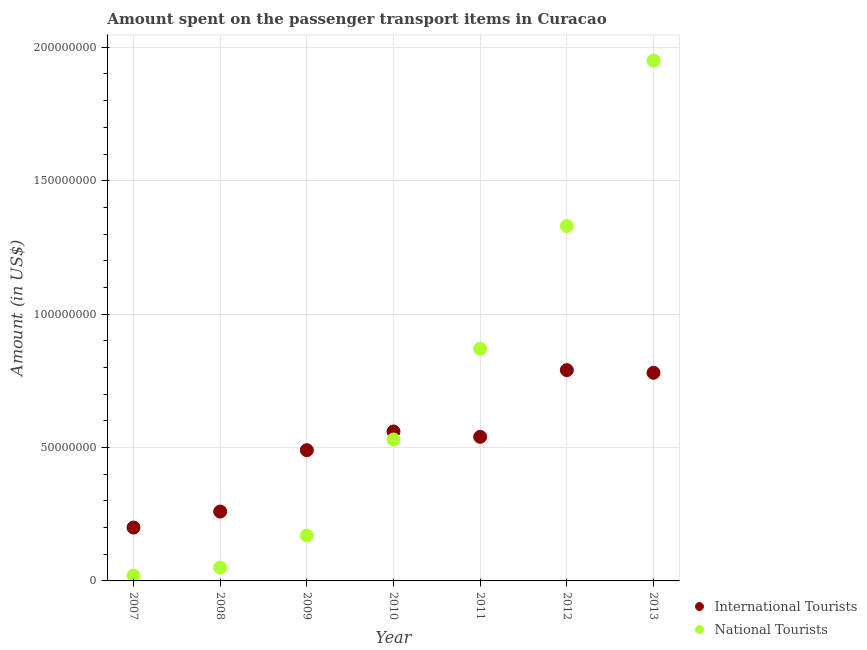Is the number of dotlines equal to the number of legend labels?
Your response must be concise. Yes. What is the amount spent on transport items of international tourists in 2008?
Your answer should be very brief. 2.60e+07. Across all years, what is the maximum amount spent on transport items of international tourists?
Give a very brief answer. 7.90e+07. Across all years, what is the minimum amount spent on transport items of national tourists?
Your answer should be compact. 2.00e+06. What is the total amount spent on transport items of national tourists in the graph?
Your response must be concise. 4.92e+08. What is the difference between the amount spent on transport items of international tourists in 2007 and that in 2008?
Your answer should be very brief. -6.00e+06. What is the difference between the amount spent on transport items of international tourists in 2011 and the amount spent on transport items of national tourists in 2009?
Provide a succinct answer. 3.70e+07. What is the average amount spent on transport items of international tourists per year?
Ensure brevity in your answer.  5.17e+07. In the year 2013, what is the difference between the amount spent on transport items of international tourists and amount spent on transport items of national tourists?
Your answer should be very brief. -1.17e+08. In how many years, is the amount spent on transport items of international tourists greater than 140000000 US$?
Your response must be concise. 0. What is the ratio of the amount spent on transport items of national tourists in 2007 to that in 2009?
Make the answer very short. 0.12. Is the amount spent on transport items of national tourists in 2007 less than that in 2008?
Your response must be concise. Yes. What is the difference between the highest and the second highest amount spent on transport items of international tourists?
Provide a succinct answer. 1.00e+06. What is the difference between the highest and the lowest amount spent on transport items of national tourists?
Your response must be concise. 1.93e+08. Is the sum of the amount spent on transport items of international tourists in 2007 and 2013 greater than the maximum amount spent on transport items of national tourists across all years?
Your answer should be compact. No. How many dotlines are there?
Offer a very short reply. 2. What is the difference between two consecutive major ticks on the Y-axis?
Your answer should be compact. 5.00e+07. Are the values on the major ticks of Y-axis written in scientific E-notation?
Provide a short and direct response. No. Does the graph contain any zero values?
Offer a terse response. No. Where does the legend appear in the graph?
Provide a succinct answer. Bottom right. How are the legend labels stacked?
Keep it short and to the point. Vertical. What is the title of the graph?
Your answer should be very brief. Amount spent on the passenger transport items in Curacao. What is the label or title of the X-axis?
Your answer should be very brief. Year. What is the Amount (in US$) in International Tourists in 2008?
Provide a succinct answer. 2.60e+07. What is the Amount (in US$) in International Tourists in 2009?
Offer a terse response. 4.90e+07. What is the Amount (in US$) in National Tourists in 2009?
Provide a succinct answer. 1.70e+07. What is the Amount (in US$) of International Tourists in 2010?
Make the answer very short. 5.60e+07. What is the Amount (in US$) of National Tourists in 2010?
Your answer should be very brief. 5.30e+07. What is the Amount (in US$) in International Tourists in 2011?
Provide a succinct answer. 5.40e+07. What is the Amount (in US$) in National Tourists in 2011?
Your response must be concise. 8.70e+07. What is the Amount (in US$) of International Tourists in 2012?
Give a very brief answer. 7.90e+07. What is the Amount (in US$) of National Tourists in 2012?
Give a very brief answer. 1.33e+08. What is the Amount (in US$) in International Tourists in 2013?
Keep it short and to the point. 7.80e+07. What is the Amount (in US$) of National Tourists in 2013?
Provide a succinct answer. 1.95e+08. Across all years, what is the maximum Amount (in US$) in International Tourists?
Your answer should be compact. 7.90e+07. Across all years, what is the maximum Amount (in US$) of National Tourists?
Give a very brief answer. 1.95e+08. Across all years, what is the minimum Amount (in US$) in National Tourists?
Make the answer very short. 2.00e+06. What is the total Amount (in US$) in International Tourists in the graph?
Keep it short and to the point. 3.62e+08. What is the total Amount (in US$) of National Tourists in the graph?
Your response must be concise. 4.92e+08. What is the difference between the Amount (in US$) in International Tourists in 2007 and that in 2008?
Offer a terse response. -6.00e+06. What is the difference between the Amount (in US$) in International Tourists in 2007 and that in 2009?
Your answer should be compact. -2.90e+07. What is the difference between the Amount (in US$) in National Tourists in 2007 and that in 2009?
Ensure brevity in your answer.  -1.50e+07. What is the difference between the Amount (in US$) of International Tourists in 2007 and that in 2010?
Offer a terse response. -3.60e+07. What is the difference between the Amount (in US$) of National Tourists in 2007 and that in 2010?
Provide a short and direct response. -5.10e+07. What is the difference between the Amount (in US$) in International Tourists in 2007 and that in 2011?
Your answer should be compact. -3.40e+07. What is the difference between the Amount (in US$) in National Tourists in 2007 and that in 2011?
Offer a terse response. -8.50e+07. What is the difference between the Amount (in US$) of International Tourists in 2007 and that in 2012?
Keep it short and to the point. -5.90e+07. What is the difference between the Amount (in US$) in National Tourists in 2007 and that in 2012?
Provide a succinct answer. -1.31e+08. What is the difference between the Amount (in US$) in International Tourists in 2007 and that in 2013?
Ensure brevity in your answer.  -5.80e+07. What is the difference between the Amount (in US$) in National Tourists in 2007 and that in 2013?
Provide a short and direct response. -1.93e+08. What is the difference between the Amount (in US$) in International Tourists in 2008 and that in 2009?
Offer a very short reply. -2.30e+07. What is the difference between the Amount (in US$) in National Tourists in 2008 and that in 2009?
Give a very brief answer. -1.20e+07. What is the difference between the Amount (in US$) in International Tourists in 2008 and that in 2010?
Offer a terse response. -3.00e+07. What is the difference between the Amount (in US$) of National Tourists in 2008 and that in 2010?
Your response must be concise. -4.80e+07. What is the difference between the Amount (in US$) in International Tourists in 2008 and that in 2011?
Provide a short and direct response. -2.80e+07. What is the difference between the Amount (in US$) in National Tourists in 2008 and that in 2011?
Offer a terse response. -8.20e+07. What is the difference between the Amount (in US$) in International Tourists in 2008 and that in 2012?
Provide a succinct answer. -5.30e+07. What is the difference between the Amount (in US$) in National Tourists in 2008 and that in 2012?
Your response must be concise. -1.28e+08. What is the difference between the Amount (in US$) of International Tourists in 2008 and that in 2013?
Provide a succinct answer. -5.20e+07. What is the difference between the Amount (in US$) in National Tourists in 2008 and that in 2013?
Give a very brief answer. -1.90e+08. What is the difference between the Amount (in US$) in International Tourists in 2009 and that in 2010?
Ensure brevity in your answer.  -7.00e+06. What is the difference between the Amount (in US$) of National Tourists in 2009 and that in 2010?
Offer a terse response. -3.60e+07. What is the difference between the Amount (in US$) in International Tourists in 2009 and that in 2011?
Provide a succinct answer. -5.00e+06. What is the difference between the Amount (in US$) in National Tourists in 2009 and that in 2011?
Keep it short and to the point. -7.00e+07. What is the difference between the Amount (in US$) of International Tourists in 2009 and that in 2012?
Give a very brief answer. -3.00e+07. What is the difference between the Amount (in US$) of National Tourists in 2009 and that in 2012?
Give a very brief answer. -1.16e+08. What is the difference between the Amount (in US$) of International Tourists in 2009 and that in 2013?
Your answer should be very brief. -2.90e+07. What is the difference between the Amount (in US$) in National Tourists in 2009 and that in 2013?
Give a very brief answer. -1.78e+08. What is the difference between the Amount (in US$) of National Tourists in 2010 and that in 2011?
Provide a short and direct response. -3.40e+07. What is the difference between the Amount (in US$) in International Tourists in 2010 and that in 2012?
Provide a short and direct response. -2.30e+07. What is the difference between the Amount (in US$) in National Tourists in 2010 and that in 2012?
Your answer should be very brief. -8.00e+07. What is the difference between the Amount (in US$) in International Tourists in 2010 and that in 2013?
Provide a short and direct response. -2.20e+07. What is the difference between the Amount (in US$) of National Tourists in 2010 and that in 2013?
Provide a succinct answer. -1.42e+08. What is the difference between the Amount (in US$) of International Tourists in 2011 and that in 2012?
Make the answer very short. -2.50e+07. What is the difference between the Amount (in US$) in National Tourists in 2011 and that in 2012?
Offer a very short reply. -4.60e+07. What is the difference between the Amount (in US$) in International Tourists in 2011 and that in 2013?
Provide a succinct answer. -2.40e+07. What is the difference between the Amount (in US$) of National Tourists in 2011 and that in 2013?
Keep it short and to the point. -1.08e+08. What is the difference between the Amount (in US$) of International Tourists in 2012 and that in 2013?
Provide a short and direct response. 1.00e+06. What is the difference between the Amount (in US$) in National Tourists in 2012 and that in 2013?
Keep it short and to the point. -6.20e+07. What is the difference between the Amount (in US$) in International Tourists in 2007 and the Amount (in US$) in National Tourists in 2008?
Your answer should be compact. 1.50e+07. What is the difference between the Amount (in US$) of International Tourists in 2007 and the Amount (in US$) of National Tourists in 2009?
Offer a very short reply. 3.00e+06. What is the difference between the Amount (in US$) in International Tourists in 2007 and the Amount (in US$) in National Tourists in 2010?
Make the answer very short. -3.30e+07. What is the difference between the Amount (in US$) in International Tourists in 2007 and the Amount (in US$) in National Tourists in 2011?
Offer a very short reply. -6.70e+07. What is the difference between the Amount (in US$) of International Tourists in 2007 and the Amount (in US$) of National Tourists in 2012?
Your answer should be very brief. -1.13e+08. What is the difference between the Amount (in US$) of International Tourists in 2007 and the Amount (in US$) of National Tourists in 2013?
Keep it short and to the point. -1.75e+08. What is the difference between the Amount (in US$) of International Tourists in 2008 and the Amount (in US$) of National Tourists in 2009?
Keep it short and to the point. 9.00e+06. What is the difference between the Amount (in US$) of International Tourists in 2008 and the Amount (in US$) of National Tourists in 2010?
Your response must be concise. -2.70e+07. What is the difference between the Amount (in US$) in International Tourists in 2008 and the Amount (in US$) in National Tourists in 2011?
Your answer should be very brief. -6.10e+07. What is the difference between the Amount (in US$) in International Tourists in 2008 and the Amount (in US$) in National Tourists in 2012?
Provide a short and direct response. -1.07e+08. What is the difference between the Amount (in US$) in International Tourists in 2008 and the Amount (in US$) in National Tourists in 2013?
Offer a very short reply. -1.69e+08. What is the difference between the Amount (in US$) in International Tourists in 2009 and the Amount (in US$) in National Tourists in 2010?
Your answer should be compact. -4.00e+06. What is the difference between the Amount (in US$) in International Tourists in 2009 and the Amount (in US$) in National Tourists in 2011?
Your answer should be compact. -3.80e+07. What is the difference between the Amount (in US$) in International Tourists in 2009 and the Amount (in US$) in National Tourists in 2012?
Ensure brevity in your answer.  -8.40e+07. What is the difference between the Amount (in US$) in International Tourists in 2009 and the Amount (in US$) in National Tourists in 2013?
Provide a short and direct response. -1.46e+08. What is the difference between the Amount (in US$) of International Tourists in 2010 and the Amount (in US$) of National Tourists in 2011?
Provide a succinct answer. -3.10e+07. What is the difference between the Amount (in US$) in International Tourists in 2010 and the Amount (in US$) in National Tourists in 2012?
Offer a terse response. -7.70e+07. What is the difference between the Amount (in US$) of International Tourists in 2010 and the Amount (in US$) of National Tourists in 2013?
Your answer should be compact. -1.39e+08. What is the difference between the Amount (in US$) of International Tourists in 2011 and the Amount (in US$) of National Tourists in 2012?
Provide a succinct answer. -7.90e+07. What is the difference between the Amount (in US$) of International Tourists in 2011 and the Amount (in US$) of National Tourists in 2013?
Your answer should be very brief. -1.41e+08. What is the difference between the Amount (in US$) of International Tourists in 2012 and the Amount (in US$) of National Tourists in 2013?
Provide a succinct answer. -1.16e+08. What is the average Amount (in US$) in International Tourists per year?
Give a very brief answer. 5.17e+07. What is the average Amount (in US$) of National Tourists per year?
Ensure brevity in your answer.  7.03e+07. In the year 2007, what is the difference between the Amount (in US$) in International Tourists and Amount (in US$) in National Tourists?
Make the answer very short. 1.80e+07. In the year 2008, what is the difference between the Amount (in US$) of International Tourists and Amount (in US$) of National Tourists?
Offer a very short reply. 2.10e+07. In the year 2009, what is the difference between the Amount (in US$) in International Tourists and Amount (in US$) in National Tourists?
Keep it short and to the point. 3.20e+07. In the year 2011, what is the difference between the Amount (in US$) in International Tourists and Amount (in US$) in National Tourists?
Offer a very short reply. -3.30e+07. In the year 2012, what is the difference between the Amount (in US$) in International Tourists and Amount (in US$) in National Tourists?
Your response must be concise. -5.40e+07. In the year 2013, what is the difference between the Amount (in US$) in International Tourists and Amount (in US$) in National Tourists?
Your response must be concise. -1.17e+08. What is the ratio of the Amount (in US$) in International Tourists in 2007 to that in 2008?
Your answer should be very brief. 0.77. What is the ratio of the Amount (in US$) in International Tourists in 2007 to that in 2009?
Provide a succinct answer. 0.41. What is the ratio of the Amount (in US$) of National Tourists in 2007 to that in 2009?
Offer a very short reply. 0.12. What is the ratio of the Amount (in US$) of International Tourists in 2007 to that in 2010?
Ensure brevity in your answer.  0.36. What is the ratio of the Amount (in US$) of National Tourists in 2007 to that in 2010?
Your answer should be very brief. 0.04. What is the ratio of the Amount (in US$) in International Tourists in 2007 to that in 2011?
Your answer should be compact. 0.37. What is the ratio of the Amount (in US$) in National Tourists in 2007 to that in 2011?
Provide a short and direct response. 0.02. What is the ratio of the Amount (in US$) in International Tourists in 2007 to that in 2012?
Offer a very short reply. 0.25. What is the ratio of the Amount (in US$) in National Tourists in 2007 to that in 2012?
Your answer should be compact. 0.01. What is the ratio of the Amount (in US$) of International Tourists in 2007 to that in 2013?
Ensure brevity in your answer.  0.26. What is the ratio of the Amount (in US$) of National Tourists in 2007 to that in 2013?
Make the answer very short. 0.01. What is the ratio of the Amount (in US$) in International Tourists in 2008 to that in 2009?
Offer a terse response. 0.53. What is the ratio of the Amount (in US$) of National Tourists in 2008 to that in 2009?
Your response must be concise. 0.29. What is the ratio of the Amount (in US$) of International Tourists in 2008 to that in 2010?
Your answer should be compact. 0.46. What is the ratio of the Amount (in US$) of National Tourists in 2008 to that in 2010?
Make the answer very short. 0.09. What is the ratio of the Amount (in US$) in International Tourists in 2008 to that in 2011?
Ensure brevity in your answer.  0.48. What is the ratio of the Amount (in US$) in National Tourists in 2008 to that in 2011?
Your response must be concise. 0.06. What is the ratio of the Amount (in US$) of International Tourists in 2008 to that in 2012?
Provide a succinct answer. 0.33. What is the ratio of the Amount (in US$) of National Tourists in 2008 to that in 2012?
Your answer should be compact. 0.04. What is the ratio of the Amount (in US$) in International Tourists in 2008 to that in 2013?
Provide a succinct answer. 0.33. What is the ratio of the Amount (in US$) of National Tourists in 2008 to that in 2013?
Your response must be concise. 0.03. What is the ratio of the Amount (in US$) of National Tourists in 2009 to that in 2010?
Provide a succinct answer. 0.32. What is the ratio of the Amount (in US$) of International Tourists in 2009 to that in 2011?
Ensure brevity in your answer.  0.91. What is the ratio of the Amount (in US$) in National Tourists in 2009 to that in 2011?
Offer a very short reply. 0.2. What is the ratio of the Amount (in US$) of International Tourists in 2009 to that in 2012?
Provide a short and direct response. 0.62. What is the ratio of the Amount (in US$) in National Tourists in 2009 to that in 2012?
Keep it short and to the point. 0.13. What is the ratio of the Amount (in US$) in International Tourists in 2009 to that in 2013?
Your answer should be very brief. 0.63. What is the ratio of the Amount (in US$) in National Tourists in 2009 to that in 2013?
Your response must be concise. 0.09. What is the ratio of the Amount (in US$) of National Tourists in 2010 to that in 2011?
Your answer should be very brief. 0.61. What is the ratio of the Amount (in US$) in International Tourists in 2010 to that in 2012?
Your response must be concise. 0.71. What is the ratio of the Amount (in US$) of National Tourists in 2010 to that in 2012?
Make the answer very short. 0.4. What is the ratio of the Amount (in US$) of International Tourists in 2010 to that in 2013?
Provide a succinct answer. 0.72. What is the ratio of the Amount (in US$) in National Tourists in 2010 to that in 2013?
Offer a very short reply. 0.27. What is the ratio of the Amount (in US$) of International Tourists in 2011 to that in 2012?
Offer a very short reply. 0.68. What is the ratio of the Amount (in US$) of National Tourists in 2011 to that in 2012?
Ensure brevity in your answer.  0.65. What is the ratio of the Amount (in US$) of International Tourists in 2011 to that in 2013?
Keep it short and to the point. 0.69. What is the ratio of the Amount (in US$) in National Tourists in 2011 to that in 2013?
Your answer should be very brief. 0.45. What is the ratio of the Amount (in US$) in International Tourists in 2012 to that in 2013?
Your response must be concise. 1.01. What is the ratio of the Amount (in US$) of National Tourists in 2012 to that in 2013?
Keep it short and to the point. 0.68. What is the difference between the highest and the second highest Amount (in US$) in National Tourists?
Provide a short and direct response. 6.20e+07. What is the difference between the highest and the lowest Amount (in US$) of International Tourists?
Your answer should be compact. 5.90e+07. What is the difference between the highest and the lowest Amount (in US$) in National Tourists?
Keep it short and to the point. 1.93e+08. 